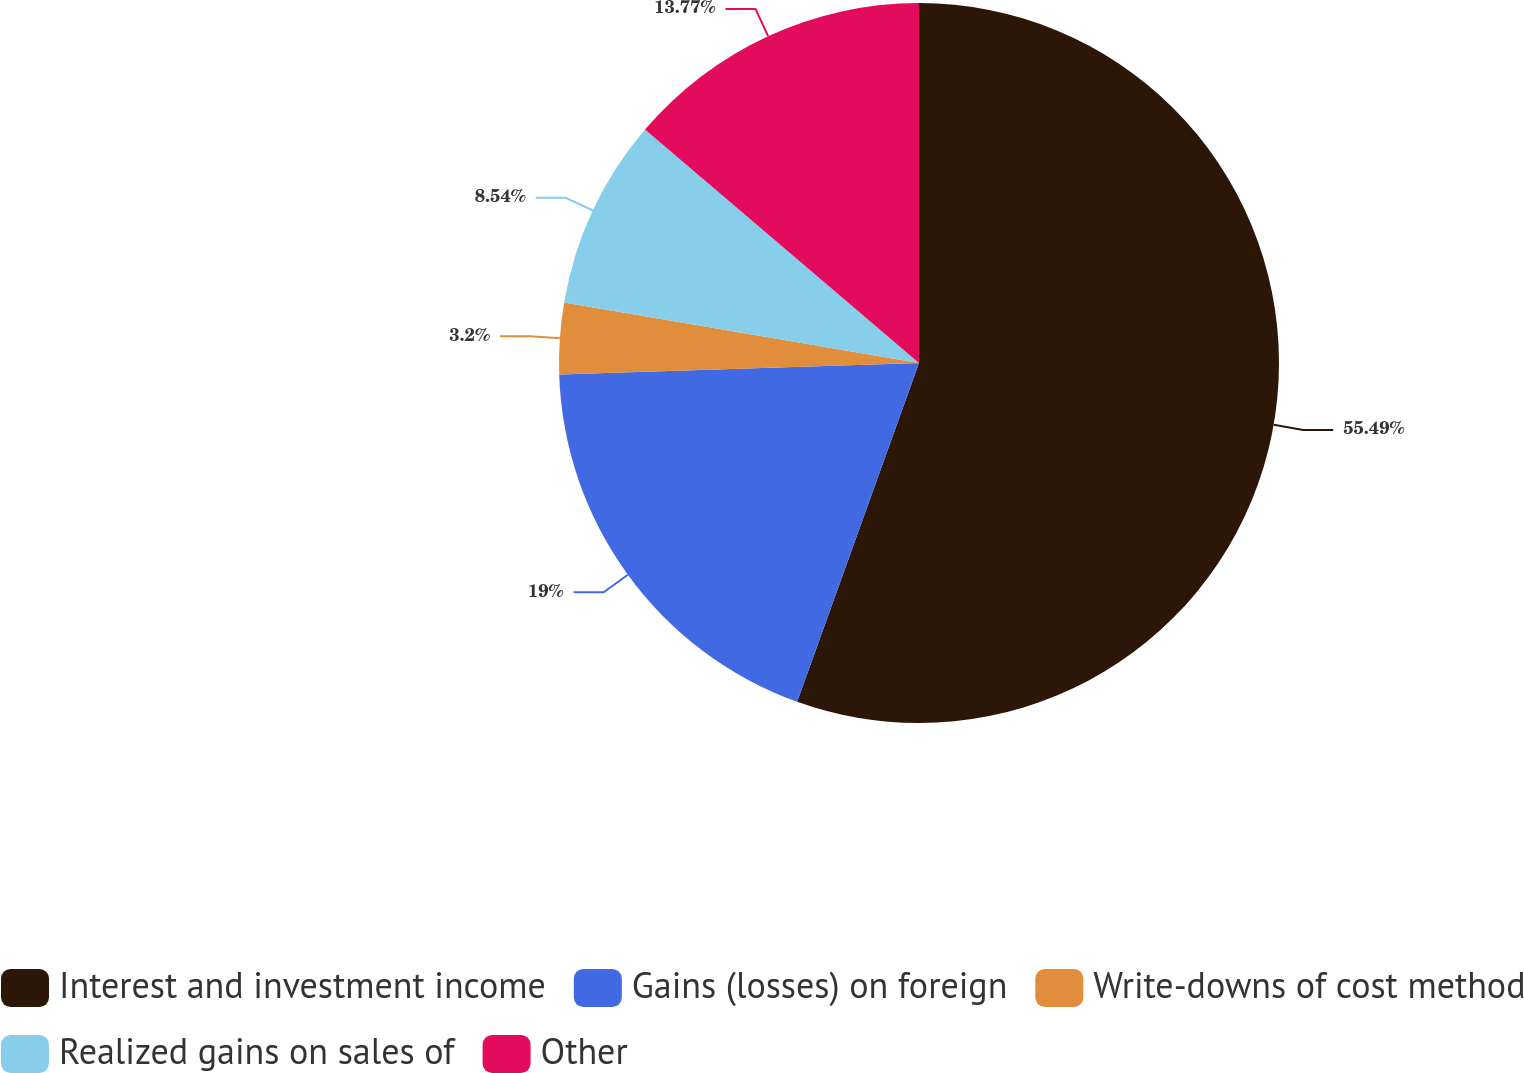<chart> <loc_0><loc_0><loc_500><loc_500><pie_chart><fcel>Interest and investment income<fcel>Gains (losses) on foreign<fcel>Write-downs of cost method<fcel>Realized gains on sales of<fcel>Other<nl><fcel>55.5%<fcel>19.0%<fcel>3.2%<fcel>8.54%<fcel>13.77%<nl></chart> 